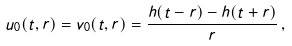Convert formula to latex. <formula><loc_0><loc_0><loc_500><loc_500>u _ { 0 } ( t , r ) = v _ { 0 } ( t , r ) = \frac { h ( t - r ) - h ( t + r ) } { r } \, ,</formula> 